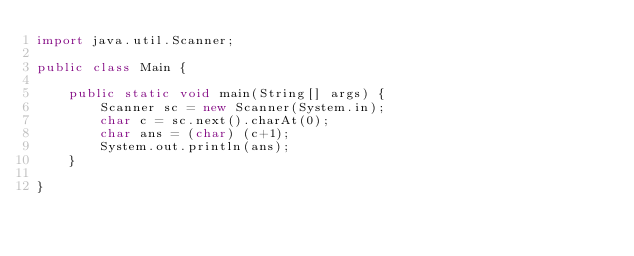<code> <loc_0><loc_0><loc_500><loc_500><_Java_>import java.util.Scanner;

public class Main {

	public static void main(String[] args) {
		Scanner sc = new Scanner(System.in);
		char c = sc.next().charAt(0);
		char ans = (char) (c+1);
		System.out.println(ans);
	}

}
</code> 